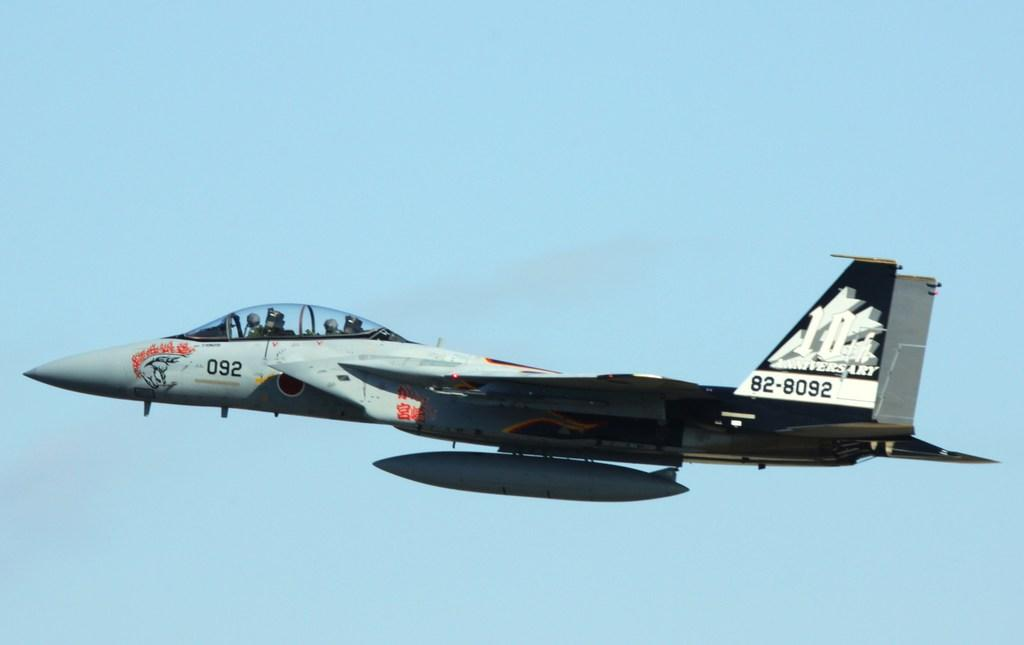<image>
Create a compact narrative representing the image presented. a 10th anniversary plane is flying through the sky 